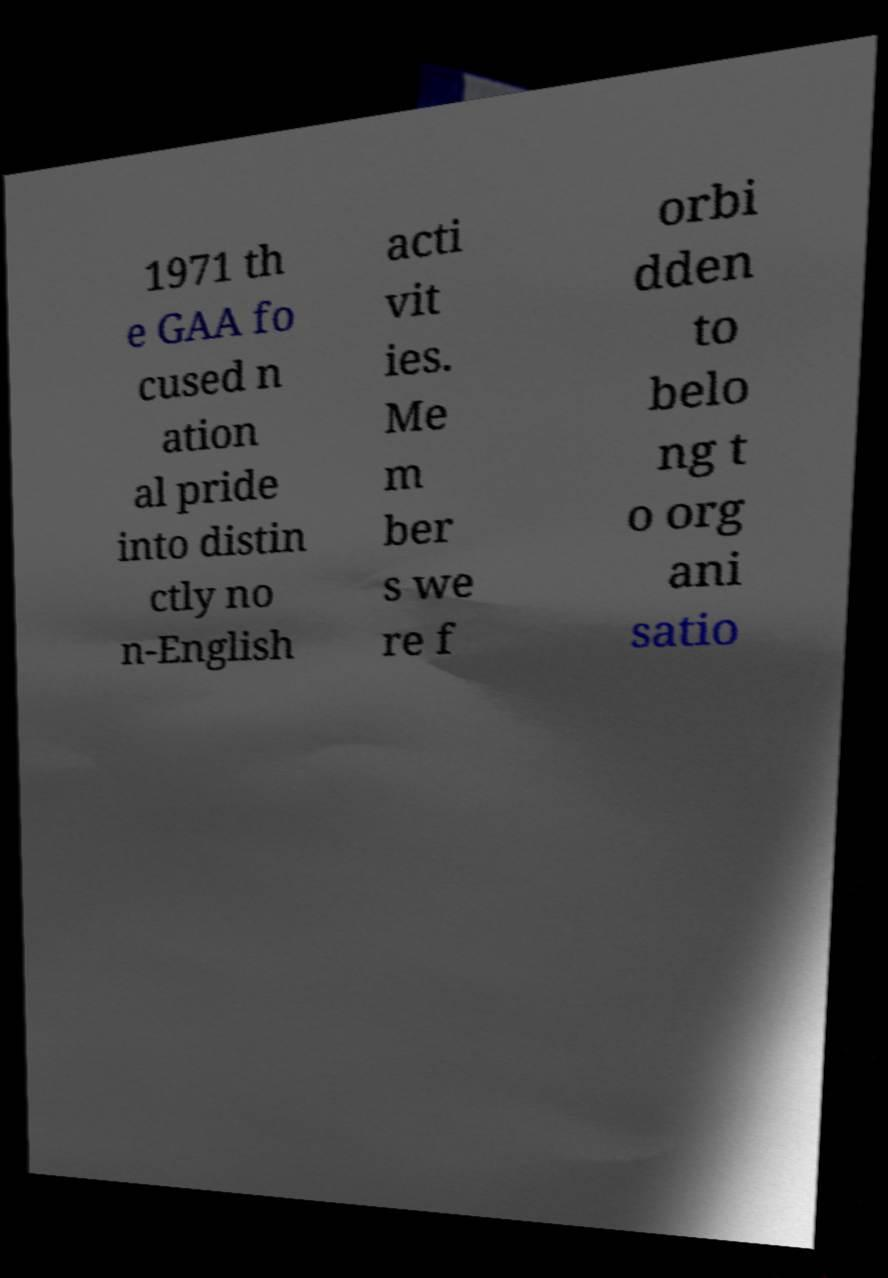Can you read and provide the text displayed in the image?This photo seems to have some interesting text. Can you extract and type it out for me? 1971 th e GAA fo cused n ation al pride into distin ctly no n-English acti vit ies. Me m ber s we re f orbi dden to belo ng t o org ani satio 